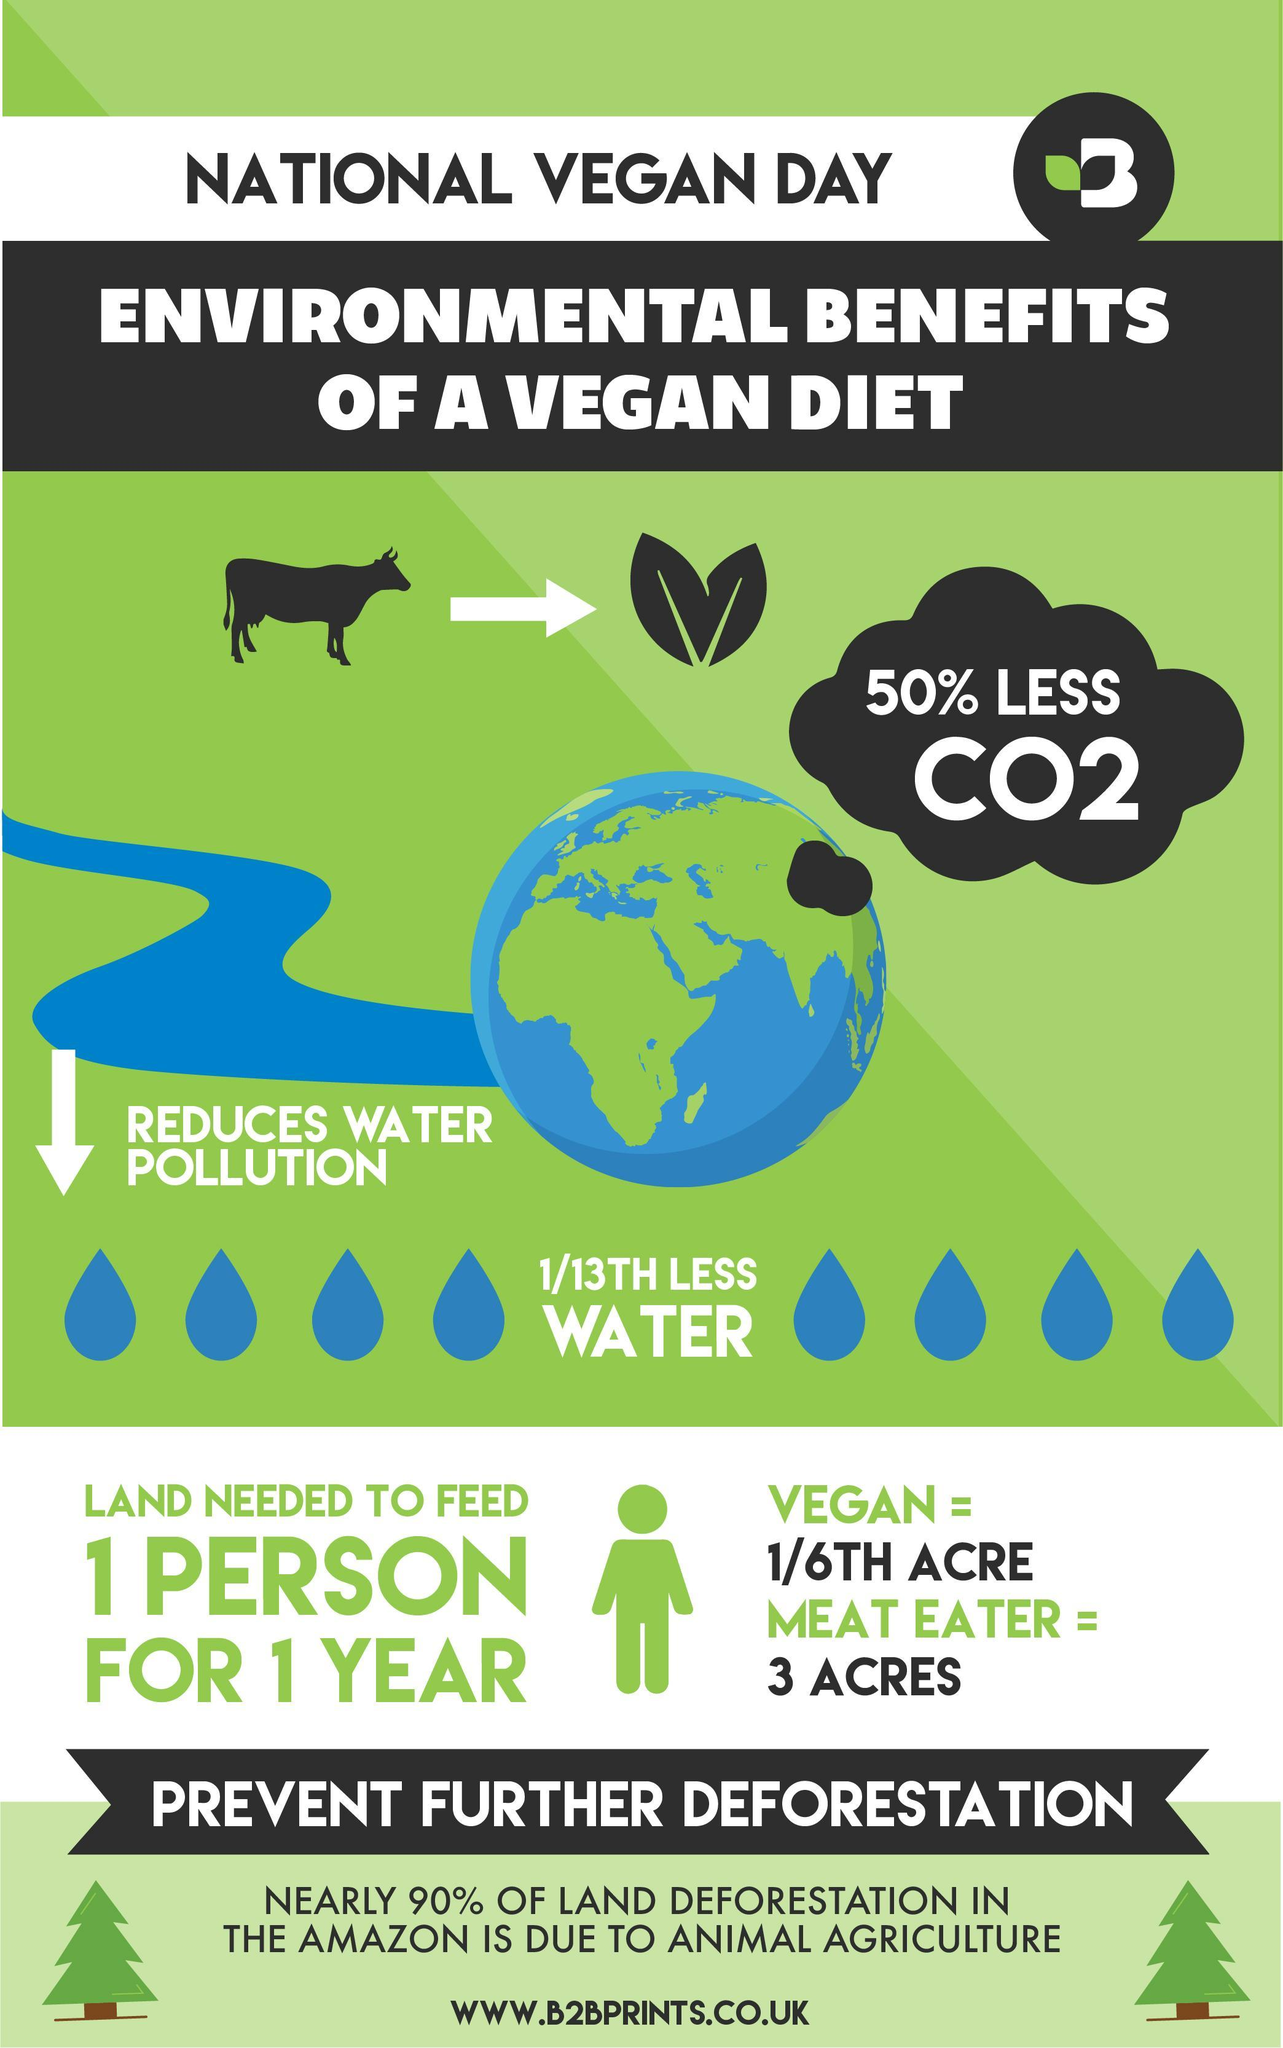Calculate is the land needed to feed a vegan in square feet?
Answer the question with a short phrase. 6969.6 